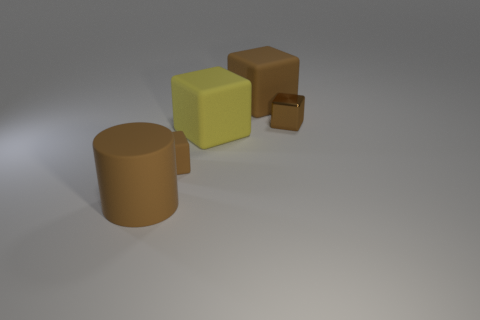Do the small shiny block and the large cylinder have the same color?
Your answer should be very brief. Yes. What number of small cubes are on the left side of the tiny metallic cube and on the right side of the yellow matte thing?
Offer a terse response. 0. Are there more brown rubber blocks that are in front of the metal object than matte cylinders that are behind the big yellow rubber object?
Offer a very short reply. Yes. What is the size of the yellow block?
Give a very brief answer. Large. Are there any other yellow rubber objects that have the same shape as the big yellow rubber object?
Offer a very short reply. No. There is a small matte thing; is it the same shape as the matte object on the left side of the small matte cube?
Provide a succinct answer. No. How big is the brown object that is both behind the tiny brown rubber cube and to the left of the brown metal block?
Ensure brevity in your answer.  Large. How many big purple matte things are there?
Keep it short and to the point. 0. Is there another brown thing of the same size as the shiny object?
Give a very brief answer. Yes. There is a large matte cube that is behind the large yellow block; does it have the same color as the small cube on the left side of the large yellow rubber block?
Your answer should be very brief. Yes. 